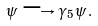Convert formula to latex. <formula><loc_0><loc_0><loc_500><loc_500>\psi \longrightarrow \gamma _ { 5 } \psi \, .</formula> 